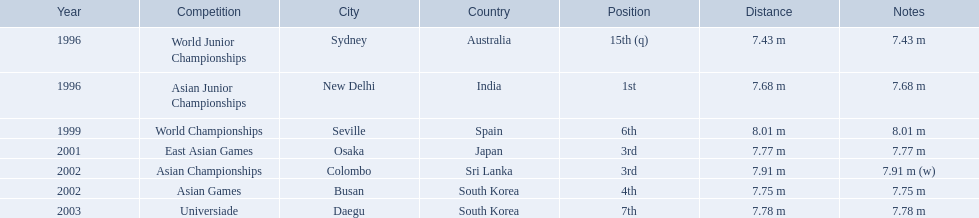Which competition did huang le achieve 3rd place? East Asian Games. Which competition did he achieve 4th place? Asian Games. When did he achieve 1st place? Asian Junior Championships. 